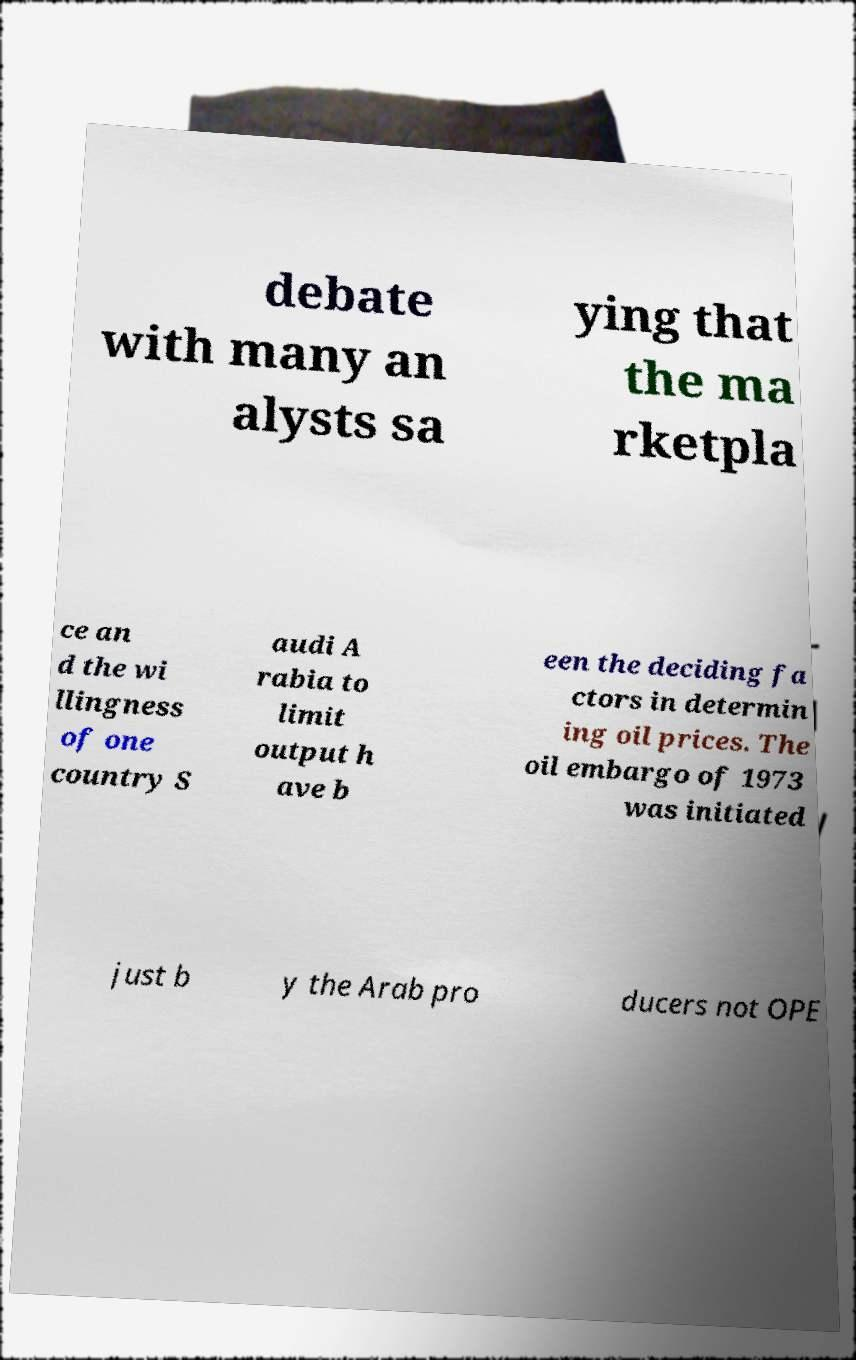Please read and relay the text visible in this image. What does it say? debate with many an alysts sa ying that the ma rketpla ce an d the wi llingness of one country S audi A rabia to limit output h ave b een the deciding fa ctors in determin ing oil prices. The oil embargo of 1973 was initiated just b y the Arab pro ducers not OPE 